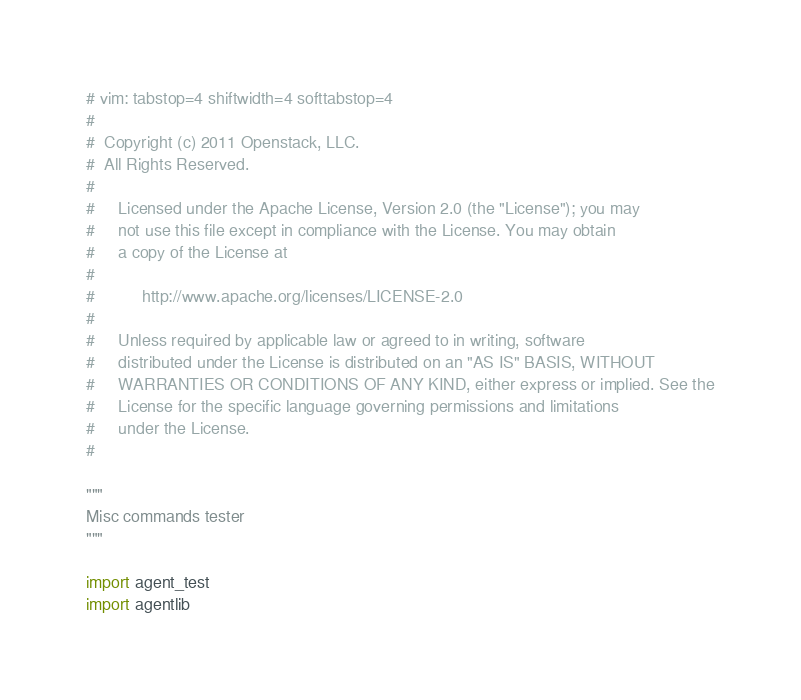<code> <loc_0><loc_0><loc_500><loc_500><_Python_># vim: tabstop=4 shiftwidth=4 softtabstop=4
#
#  Copyright (c) 2011 Openstack, LLC.
#  All Rights Reserved.
#
#     Licensed under the Apache License, Version 2.0 (the "License"); you may
#     not use this file except in compliance with the License. You may obtain
#     a copy of the License at
#
#          http://www.apache.org/licenses/LICENSE-2.0
#
#     Unless required by applicable law or agreed to in writing, software
#     distributed under the License is distributed on an "AS IS" BASIS, WITHOUT
#     WARRANTIES OR CONDITIONS OF ANY KIND, either express or implied. See the
#     License for the specific language governing permissions and limitations
#     under the License.
#

"""
Misc commands tester
"""

import agent_test
import agentlib</code> 